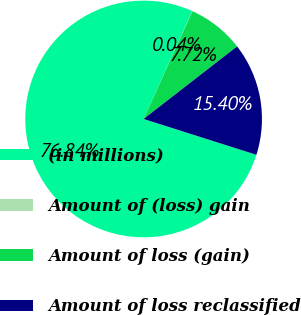Convert chart to OTSL. <chart><loc_0><loc_0><loc_500><loc_500><pie_chart><fcel>(in millions)<fcel>Amount of (loss) gain<fcel>Amount of loss (gain)<fcel>Amount of loss reclassified<nl><fcel>76.84%<fcel>0.04%<fcel>7.72%<fcel>15.4%<nl></chart> 